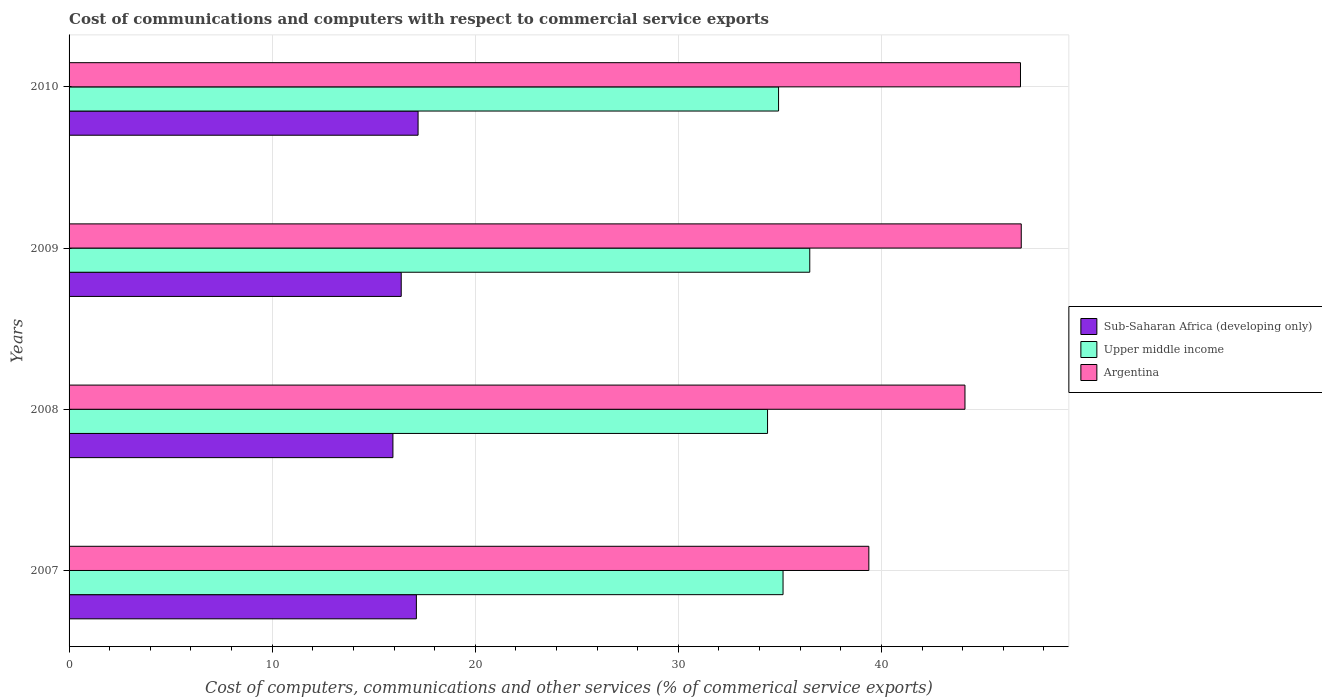Are the number of bars per tick equal to the number of legend labels?
Keep it short and to the point. Yes. Are the number of bars on each tick of the Y-axis equal?
Ensure brevity in your answer.  Yes. How many bars are there on the 4th tick from the top?
Offer a very short reply. 3. How many bars are there on the 4th tick from the bottom?
Offer a terse response. 3. What is the label of the 2nd group of bars from the top?
Ensure brevity in your answer.  2009. In how many cases, is the number of bars for a given year not equal to the number of legend labels?
Provide a succinct answer. 0. What is the cost of communications and computers in Argentina in 2008?
Your answer should be very brief. 44.11. Across all years, what is the maximum cost of communications and computers in Sub-Saharan Africa (developing only)?
Your answer should be very brief. 17.18. Across all years, what is the minimum cost of communications and computers in Argentina?
Ensure brevity in your answer.  39.38. In which year was the cost of communications and computers in Argentina maximum?
Offer a terse response. 2009. In which year was the cost of communications and computers in Sub-Saharan Africa (developing only) minimum?
Your answer should be compact. 2008. What is the total cost of communications and computers in Argentina in the graph?
Offer a very short reply. 177.22. What is the difference between the cost of communications and computers in Argentina in 2007 and that in 2009?
Your answer should be very brief. -7.5. What is the difference between the cost of communications and computers in Argentina in 2009 and the cost of communications and computers in Upper middle income in 2008?
Your response must be concise. 12.49. What is the average cost of communications and computers in Upper middle income per year?
Ensure brevity in your answer.  35.24. In the year 2009, what is the difference between the cost of communications and computers in Argentina and cost of communications and computers in Upper middle income?
Offer a very short reply. 10.41. In how many years, is the cost of communications and computers in Argentina greater than 46 %?
Provide a succinct answer. 2. What is the ratio of the cost of communications and computers in Sub-Saharan Africa (developing only) in 2007 to that in 2009?
Keep it short and to the point. 1.05. What is the difference between the highest and the second highest cost of communications and computers in Sub-Saharan Africa (developing only)?
Give a very brief answer. 0.08. What is the difference between the highest and the lowest cost of communications and computers in Upper middle income?
Give a very brief answer. 2.08. In how many years, is the cost of communications and computers in Upper middle income greater than the average cost of communications and computers in Upper middle income taken over all years?
Your answer should be very brief. 1. Is the sum of the cost of communications and computers in Argentina in 2009 and 2010 greater than the maximum cost of communications and computers in Sub-Saharan Africa (developing only) across all years?
Provide a succinct answer. Yes. What does the 3rd bar from the bottom in 2009 represents?
Your response must be concise. Argentina. Are all the bars in the graph horizontal?
Your response must be concise. Yes. How many years are there in the graph?
Give a very brief answer. 4. What is the difference between two consecutive major ticks on the X-axis?
Ensure brevity in your answer.  10. Does the graph contain grids?
Give a very brief answer. Yes. Where does the legend appear in the graph?
Offer a very short reply. Center right. What is the title of the graph?
Offer a very short reply. Cost of communications and computers with respect to commercial service exports. What is the label or title of the X-axis?
Offer a terse response. Cost of computers, communications and other services (% of commerical service exports). What is the Cost of computers, communications and other services (% of commerical service exports) of Sub-Saharan Africa (developing only) in 2007?
Keep it short and to the point. 17.1. What is the Cost of computers, communications and other services (% of commerical service exports) in Upper middle income in 2007?
Keep it short and to the point. 35.15. What is the Cost of computers, communications and other services (% of commerical service exports) in Argentina in 2007?
Your answer should be very brief. 39.38. What is the Cost of computers, communications and other services (% of commerical service exports) of Sub-Saharan Africa (developing only) in 2008?
Provide a succinct answer. 15.95. What is the Cost of computers, communications and other services (% of commerical service exports) of Upper middle income in 2008?
Offer a very short reply. 34.39. What is the Cost of computers, communications and other services (% of commerical service exports) of Argentina in 2008?
Your answer should be very brief. 44.11. What is the Cost of computers, communications and other services (% of commerical service exports) in Sub-Saharan Africa (developing only) in 2009?
Your answer should be very brief. 16.35. What is the Cost of computers, communications and other services (% of commerical service exports) of Upper middle income in 2009?
Your answer should be very brief. 36.47. What is the Cost of computers, communications and other services (% of commerical service exports) of Argentina in 2009?
Make the answer very short. 46.88. What is the Cost of computers, communications and other services (% of commerical service exports) of Sub-Saharan Africa (developing only) in 2010?
Make the answer very short. 17.18. What is the Cost of computers, communications and other services (% of commerical service exports) in Upper middle income in 2010?
Your answer should be very brief. 34.93. What is the Cost of computers, communications and other services (% of commerical service exports) of Argentina in 2010?
Offer a terse response. 46.85. Across all years, what is the maximum Cost of computers, communications and other services (% of commerical service exports) in Sub-Saharan Africa (developing only)?
Offer a terse response. 17.18. Across all years, what is the maximum Cost of computers, communications and other services (% of commerical service exports) in Upper middle income?
Offer a very short reply. 36.47. Across all years, what is the maximum Cost of computers, communications and other services (% of commerical service exports) in Argentina?
Provide a short and direct response. 46.88. Across all years, what is the minimum Cost of computers, communications and other services (% of commerical service exports) of Sub-Saharan Africa (developing only)?
Provide a short and direct response. 15.95. Across all years, what is the minimum Cost of computers, communications and other services (% of commerical service exports) of Upper middle income?
Provide a short and direct response. 34.39. Across all years, what is the minimum Cost of computers, communications and other services (% of commerical service exports) of Argentina?
Provide a short and direct response. 39.38. What is the total Cost of computers, communications and other services (% of commerical service exports) in Sub-Saharan Africa (developing only) in the graph?
Provide a short and direct response. 66.59. What is the total Cost of computers, communications and other services (% of commerical service exports) of Upper middle income in the graph?
Make the answer very short. 140.95. What is the total Cost of computers, communications and other services (% of commerical service exports) of Argentina in the graph?
Provide a short and direct response. 177.22. What is the difference between the Cost of computers, communications and other services (% of commerical service exports) in Sub-Saharan Africa (developing only) in 2007 and that in 2008?
Your response must be concise. 1.15. What is the difference between the Cost of computers, communications and other services (% of commerical service exports) of Upper middle income in 2007 and that in 2008?
Your answer should be very brief. 0.76. What is the difference between the Cost of computers, communications and other services (% of commerical service exports) of Argentina in 2007 and that in 2008?
Ensure brevity in your answer.  -4.73. What is the difference between the Cost of computers, communications and other services (% of commerical service exports) in Sub-Saharan Africa (developing only) in 2007 and that in 2009?
Give a very brief answer. 0.75. What is the difference between the Cost of computers, communications and other services (% of commerical service exports) in Upper middle income in 2007 and that in 2009?
Make the answer very short. -1.32. What is the difference between the Cost of computers, communications and other services (% of commerical service exports) in Argentina in 2007 and that in 2009?
Your answer should be very brief. -7.5. What is the difference between the Cost of computers, communications and other services (% of commerical service exports) in Sub-Saharan Africa (developing only) in 2007 and that in 2010?
Ensure brevity in your answer.  -0.08. What is the difference between the Cost of computers, communications and other services (% of commerical service exports) of Upper middle income in 2007 and that in 2010?
Ensure brevity in your answer.  0.22. What is the difference between the Cost of computers, communications and other services (% of commerical service exports) in Argentina in 2007 and that in 2010?
Ensure brevity in your answer.  -7.47. What is the difference between the Cost of computers, communications and other services (% of commerical service exports) of Sub-Saharan Africa (developing only) in 2008 and that in 2009?
Ensure brevity in your answer.  -0.41. What is the difference between the Cost of computers, communications and other services (% of commerical service exports) of Upper middle income in 2008 and that in 2009?
Your answer should be compact. -2.08. What is the difference between the Cost of computers, communications and other services (% of commerical service exports) in Argentina in 2008 and that in 2009?
Provide a succinct answer. -2.77. What is the difference between the Cost of computers, communications and other services (% of commerical service exports) of Sub-Saharan Africa (developing only) in 2008 and that in 2010?
Offer a very short reply. -1.24. What is the difference between the Cost of computers, communications and other services (% of commerical service exports) of Upper middle income in 2008 and that in 2010?
Your response must be concise. -0.54. What is the difference between the Cost of computers, communications and other services (% of commerical service exports) of Argentina in 2008 and that in 2010?
Give a very brief answer. -2.73. What is the difference between the Cost of computers, communications and other services (% of commerical service exports) in Sub-Saharan Africa (developing only) in 2009 and that in 2010?
Give a very brief answer. -0.83. What is the difference between the Cost of computers, communications and other services (% of commerical service exports) in Upper middle income in 2009 and that in 2010?
Offer a very short reply. 1.54. What is the difference between the Cost of computers, communications and other services (% of commerical service exports) in Argentina in 2009 and that in 2010?
Your response must be concise. 0.04. What is the difference between the Cost of computers, communications and other services (% of commerical service exports) in Sub-Saharan Africa (developing only) in 2007 and the Cost of computers, communications and other services (% of commerical service exports) in Upper middle income in 2008?
Your response must be concise. -17.29. What is the difference between the Cost of computers, communications and other services (% of commerical service exports) in Sub-Saharan Africa (developing only) in 2007 and the Cost of computers, communications and other services (% of commerical service exports) in Argentina in 2008?
Provide a short and direct response. -27.01. What is the difference between the Cost of computers, communications and other services (% of commerical service exports) in Upper middle income in 2007 and the Cost of computers, communications and other services (% of commerical service exports) in Argentina in 2008?
Provide a succinct answer. -8.96. What is the difference between the Cost of computers, communications and other services (% of commerical service exports) in Sub-Saharan Africa (developing only) in 2007 and the Cost of computers, communications and other services (% of commerical service exports) in Upper middle income in 2009?
Keep it short and to the point. -19.37. What is the difference between the Cost of computers, communications and other services (% of commerical service exports) in Sub-Saharan Africa (developing only) in 2007 and the Cost of computers, communications and other services (% of commerical service exports) in Argentina in 2009?
Keep it short and to the point. -29.78. What is the difference between the Cost of computers, communications and other services (% of commerical service exports) of Upper middle income in 2007 and the Cost of computers, communications and other services (% of commerical service exports) of Argentina in 2009?
Your answer should be compact. -11.73. What is the difference between the Cost of computers, communications and other services (% of commerical service exports) in Sub-Saharan Africa (developing only) in 2007 and the Cost of computers, communications and other services (% of commerical service exports) in Upper middle income in 2010?
Offer a terse response. -17.83. What is the difference between the Cost of computers, communications and other services (% of commerical service exports) of Sub-Saharan Africa (developing only) in 2007 and the Cost of computers, communications and other services (% of commerical service exports) of Argentina in 2010?
Offer a very short reply. -29.75. What is the difference between the Cost of computers, communications and other services (% of commerical service exports) of Upper middle income in 2007 and the Cost of computers, communications and other services (% of commerical service exports) of Argentina in 2010?
Provide a succinct answer. -11.69. What is the difference between the Cost of computers, communications and other services (% of commerical service exports) of Sub-Saharan Africa (developing only) in 2008 and the Cost of computers, communications and other services (% of commerical service exports) of Upper middle income in 2009?
Give a very brief answer. -20.52. What is the difference between the Cost of computers, communications and other services (% of commerical service exports) of Sub-Saharan Africa (developing only) in 2008 and the Cost of computers, communications and other services (% of commerical service exports) of Argentina in 2009?
Make the answer very short. -30.94. What is the difference between the Cost of computers, communications and other services (% of commerical service exports) of Upper middle income in 2008 and the Cost of computers, communications and other services (% of commerical service exports) of Argentina in 2009?
Provide a short and direct response. -12.49. What is the difference between the Cost of computers, communications and other services (% of commerical service exports) in Sub-Saharan Africa (developing only) in 2008 and the Cost of computers, communications and other services (% of commerical service exports) in Upper middle income in 2010?
Give a very brief answer. -18.99. What is the difference between the Cost of computers, communications and other services (% of commerical service exports) in Sub-Saharan Africa (developing only) in 2008 and the Cost of computers, communications and other services (% of commerical service exports) in Argentina in 2010?
Your answer should be compact. -30.9. What is the difference between the Cost of computers, communications and other services (% of commerical service exports) in Upper middle income in 2008 and the Cost of computers, communications and other services (% of commerical service exports) in Argentina in 2010?
Offer a terse response. -12.45. What is the difference between the Cost of computers, communications and other services (% of commerical service exports) of Sub-Saharan Africa (developing only) in 2009 and the Cost of computers, communications and other services (% of commerical service exports) of Upper middle income in 2010?
Give a very brief answer. -18.58. What is the difference between the Cost of computers, communications and other services (% of commerical service exports) of Sub-Saharan Africa (developing only) in 2009 and the Cost of computers, communications and other services (% of commerical service exports) of Argentina in 2010?
Ensure brevity in your answer.  -30.49. What is the difference between the Cost of computers, communications and other services (% of commerical service exports) of Upper middle income in 2009 and the Cost of computers, communications and other services (% of commerical service exports) of Argentina in 2010?
Make the answer very short. -10.38. What is the average Cost of computers, communications and other services (% of commerical service exports) in Sub-Saharan Africa (developing only) per year?
Ensure brevity in your answer.  16.65. What is the average Cost of computers, communications and other services (% of commerical service exports) in Upper middle income per year?
Provide a succinct answer. 35.24. What is the average Cost of computers, communications and other services (% of commerical service exports) in Argentina per year?
Ensure brevity in your answer.  44.31. In the year 2007, what is the difference between the Cost of computers, communications and other services (% of commerical service exports) of Sub-Saharan Africa (developing only) and Cost of computers, communications and other services (% of commerical service exports) of Upper middle income?
Offer a very short reply. -18.05. In the year 2007, what is the difference between the Cost of computers, communications and other services (% of commerical service exports) in Sub-Saharan Africa (developing only) and Cost of computers, communications and other services (% of commerical service exports) in Argentina?
Offer a terse response. -22.28. In the year 2007, what is the difference between the Cost of computers, communications and other services (% of commerical service exports) in Upper middle income and Cost of computers, communications and other services (% of commerical service exports) in Argentina?
Offer a very short reply. -4.23. In the year 2008, what is the difference between the Cost of computers, communications and other services (% of commerical service exports) in Sub-Saharan Africa (developing only) and Cost of computers, communications and other services (% of commerical service exports) in Upper middle income?
Offer a very short reply. -18.45. In the year 2008, what is the difference between the Cost of computers, communications and other services (% of commerical service exports) of Sub-Saharan Africa (developing only) and Cost of computers, communications and other services (% of commerical service exports) of Argentina?
Offer a terse response. -28.17. In the year 2008, what is the difference between the Cost of computers, communications and other services (% of commerical service exports) of Upper middle income and Cost of computers, communications and other services (% of commerical service exports) of Argentina?
Your answer should be very brief. -9.72. In the year 2009, what is the difference between the Cost of computers, communications and other services (% of commerical service exports) in Sub-Saharan Africa (developing only) and Cost of computers, communications and other services (% of commerical service exports) in Upper middle income?
Provide a succinct answer. -20.12. In the year 2009, what is the difference between the Cost of computers, communications and other services (% of commerical service exports) of Sub-Saharan Africa (developing only) and Cost of computers, communications and other services (% of commerical service exports) of Argentina?
Provide a succinct answer. -30.53. In the year 2009, what is the difference between the Cost of computers, communications and other services (% of commerical service exports) in Upper middle income and Cost of computers, communications and other services (% of commerical service exports) in Argentina?
Give a very brief answer. -10.41. In the year 2010, what is the difference between the Cost of computers, communications and other services (% of commerical service exports) in Sub-Saharan Africa (developing only) and Cost of computers, communications and other services (% of commerical service exports) in Upper middle income?
Ensure brevity in your answer.  -17.75. In the year 2010, what is the difference between the Cost of computers, communications and other services (% of commerical service exports) of Sub-Saharan Africa (developing only) and Cost of computers, communications and other services (% of commerical service exports) of Argentina?
Ensure brevity in your answer.  -29.66. In the year 2010, what is the difference between the Cost of computers, communications and other services (% of commerical service exports) of Upper middle income and Cost of computers, communications and other services (% of commerical service exports) of Argentina?
Offer a terse response. -11.91. What is the ratio of the Cost of computers, communications and other services (% of commerical service exports) of Sub-Saharan Africa (developing only) in 2007 to that in 2008?
Your answer should be compact. 1.07. What is the ratio of the Cost of computers, communications and other services (% of commerical service exports) in Upper middle income in 2007 to that in 2008?
Your answer should be compact. 1.02. What is the ratio of the Cost of computers, communications and other services (% of commerical service exports) in Argentina in 2007 to that in 2008?
Your answer should be compact. 0.89. What is the ratio of the Cost of computers, communications and other services (% of commerical service exports) in Sub-Saharan Africa (developing only) in 2007 to that in 2009?
Keep it short and to the point. 1.05. What is the ratio of the Cost of computers, communications and other services (% of commerical service exports) in Upper middle income in 2007 to that in 2009?
Make the answer very short. 0.96. What is the ratio of the Cost of computers, communications and other services (% of commerical service exports) in Argentina in 2007 to that in 2009?
Your response must be concise. 0.84. What is the ratio of the Cost of computers, communications and other services (% of commerical service exports) of Upper middle income in 2007 to that in 2010?
Ensure brevity in your answer.  1.01. What is the ratio of the Cost of computers, communications and other services (% of commerical service exports) in Argentina in 2007 to that in 2010?
Make the answer very short. 0.84. What is the ratio of the Cost of computers, communications and other services (% of commerical service exports) of Sub-Saharan Africa (developing only) in 2008 to that in 2009?
Your answer should be very brief. 0.97. What is the ratio of the Cost of computers, communications and other services (% of commerical service exports) of Upper middle income in 2008 to that in 2009?
Your answer should be very brief. 0.94. What is the ratio of the Cost of computers, communications and other services (% of commerical service exports) in Argentina in 2008 to that in 2009?
Provide a short and direct response. 0.94. What is the ratio of the Cost of computers, communications and other services (% of commerical service exports) of Sub-Saharan Africa (developing only) in 2008 to that in 2010?
Ensure brevity in your answer.  0.93. What is the ratio of the Cost of computers, communications and other services (% of commerical service exports) of Upper middle income in 2008 to that in 2010?
Your answer should be very brief. 0.98. What is the ratio of the Cost of computers, communications and other services (% of commerical service exports) of Argentina in 2008 to that in 2010?
Make the answer very short. 0.94. What is the ratio of the Cost of computers, communications and other services (% of commerical service exports) in Sub-Saharan Africa (developing only) in 2009 to that in 2010?
Make the answer very short. 0.95. What is the ratio of the Cost of computers, communications and other services (% of commerical service exports) of Upper middle income in 2009 to that in 2010?
Offer a very short reply. 1.04. What is the difference between the highest and the second highest Cost of computers, communications and other services (% of commerical service exports) of Sub-Saharan Africa (developing only)?
Your answer should be very brief. 0.08. What is the difference between the highest and the second highest Cost of computers, communications and other services (% of commerical service exports) in Upper middle income?
Your answer should be very brief. 1.32. What is the difference between the highest and the second highest Cost of computers, communications and other services (% of commerical service exports) in Argentina?
Offer a very short reply. 0.04. What is the difference between the highest and the lowest Cost of computers, communications and other services (% of commerical service exports) in Sub-Saharan Africa (developing only)?
Provide a succinct answer. 1.24. What is the difference between the highest and the lowest Cost of computers, communications and other services (% of commerical service exports) of Upper middle income?
Offer a terse response. 2.08. What is the difference between the highest and the lowest Cost of computers, communications and other services (% of commerical service exports) of Argentina?
Provide a short and direct response. 7.5. 